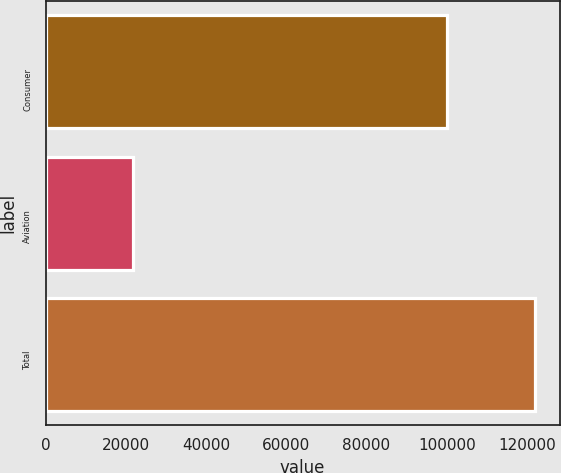Convert chart. <chart><loc_0><loc_0><loc_500><loc_500><bar_chart><fcel>Consumer<fcel>Aviation<fcel>Total<nl><fcel>100182<fcel>21839<fcel>122021<nl></chart> 